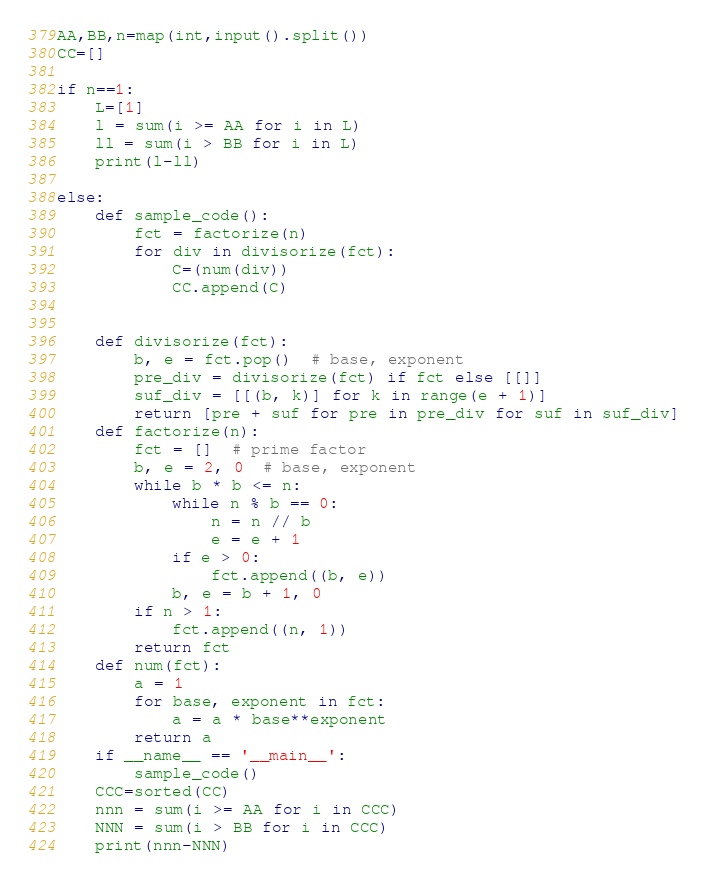<code> <loc_0><loc_0><loc_500><loc_500><_Python_>AA,BB,n=map(int,input().split())
CC=[]

if n==1:
    L=[1]
    l = sum(i >= AA for i in L)
    ll = sum(i > BB for i in L)
    print(l-ll)
    
else:
    def sample_code():
        fct = factorize(n)
        for div in divisorize(fct):
            C=(num(div))
            CC.append(C)


    def divisorize(fct):
        b, e = fct.pop()  # base, exponent
        pre_div = divisorize(fct) if fct else [[]]
        suf_div = [[(b, k)] for k in range(e + 1)]
        return [pre + suf for pre in pre_div for suf in suf_div]
    def factorize(n):
        fct = []  # prime factor
        b, e = 2, 0  # base, exponent
        while b * b <= n:
            while n % b == 0:
                n = n // b
                e = e + 1
            if e > 0:
                fct.append((b, e))
            b, e = b + 1, 0
        if n > 1:
            fct.append((n, 1))
        return fct
    def num(fct):
        a = 1
        for base, exponent in fct:
            a = a * base**exponent
        return a
    if __name__ == '__main__':
        sample_code()
    CCC=sorted(CC)
    nnn = sum(i >= AA for i in CCC)
    NNN = sum(i > BB for i in CCC)
    print(nnn-NNN)
</code> 